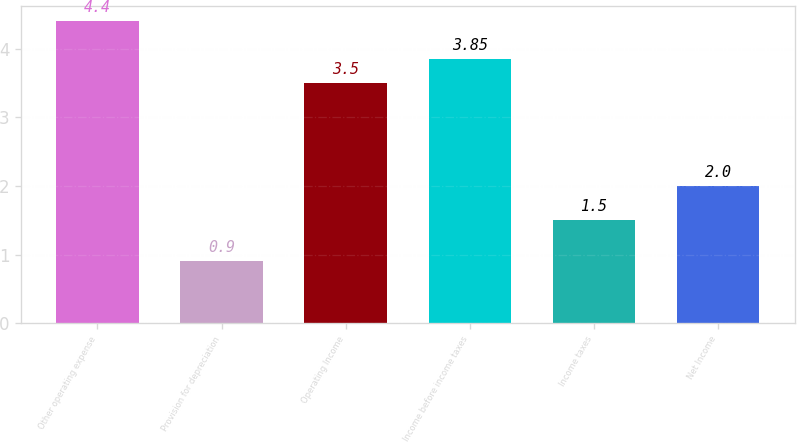Convert chart to OTSL. <chart><loc_0><loc_0><loc_500><loc_500><bar_chart><fcel>Other operating expense<fcel>Provision for depreciation<fcel>Operating Income<fcel>Income before income taxes<fcel>Income taxes<fcel>Net Income<nl><fcel>4.4<fcel>0.9<fcel>3.5<fcel>3.85<fcel>1.5<fcel>2<nl></chart> 